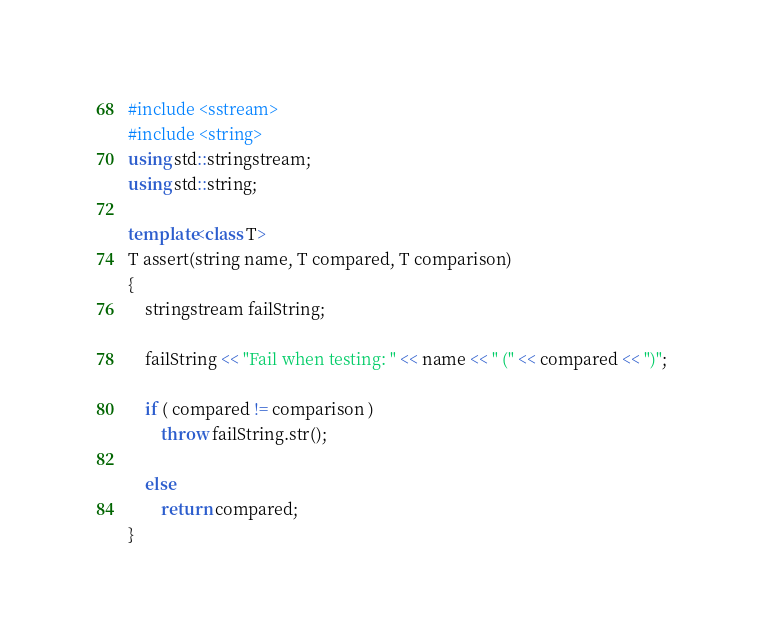<code> <loc_0><loc_0><loc_500><loc_500><_C++_>#include <sstream>
#include <string>
using std::stringstream;
using std::string;

template<class T>
T assert(string name, T compared, T comparison)
{
    stringstream failString;

    failString << "Fail when testing: " << name << " (" << compared << ")";

    if ( compared != comparison )
        throw failString.str();

    else
        return compared;
}
</code> 